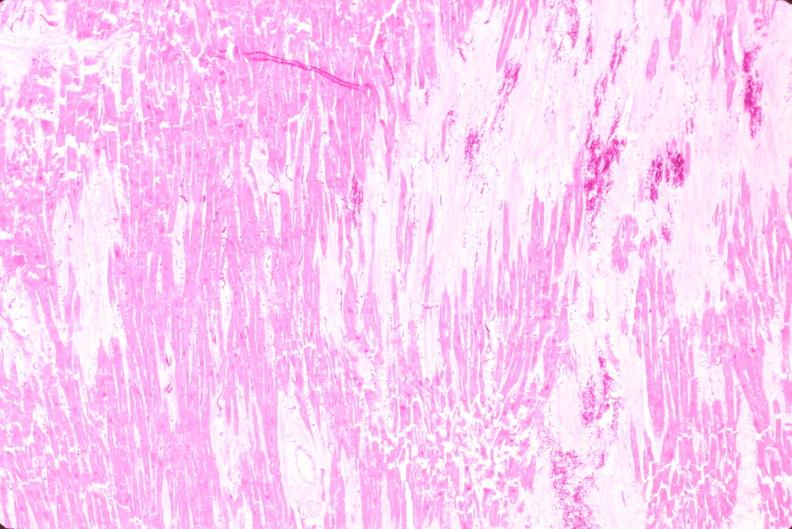does heart show heart, old myocardial infarction with fibrosis, he?
Answer the question using a single word or phrase. No 